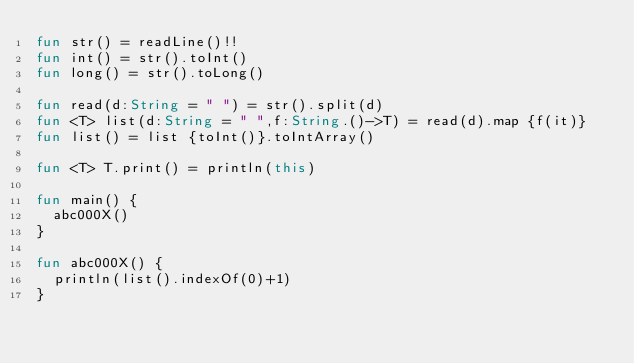<code> <loc_0><loc_0><loc_500><loc_500><_Kotlin_>fun str() = readLine()!!
fun int() = str().toInt()
fun long() = str().toLong()

fun read(d:String = " ") = str().split(d)
fun <T> list(d:String = " ",f:String.()->T) = read(d).map {f(it)}
fun list() = list {toInt()}.toIntArray()

fun <T> T.print() = println(this)

fun main() {
	abc000X()
}

fun abc000X() {
	println(list().indexOf(0)+1)
}
</code> 